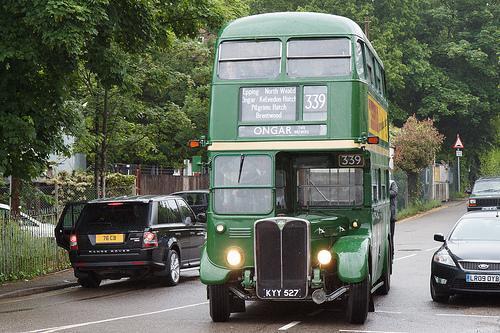How many levels does the green bus have?
Give a very brief answer. 2. How many buses are shown?
Give a very brief answer. 1. How many SUVs with car doors open?
Give a very brief answer. 1. How many blue buses are there?
Give a very brief answer. 0. How many vehicles are visible that are not buses?
Give a very brief answer. 4. How many green vehicles are in the picture?
Give a very brief answer. 1. 